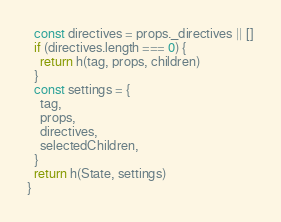<code> <loc_0><loc_0><loc_500><loc_500><_TypeScript_>  const directives = props._directives || []
  if (directives.length === 0) {
    return h(tag, props, children)
  }
  const settings = {
    tag,
    props,
    directives,
    selectedChildren,
  }
  return h(State, settings)
}
</code> 